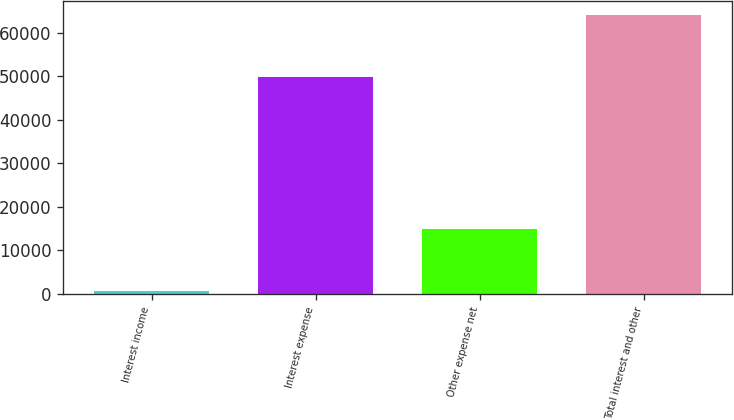Convert chart. <chart><loc_0><loc_0><loc_500><loc_500><bar_chart><fcel>Interest income<fcel>Interest expense<fcel>Other expense net<fcel>Total interest and other<nl><fcel>650<fcel>49924<fcel>14836<fcel>64110<nl></chart> 